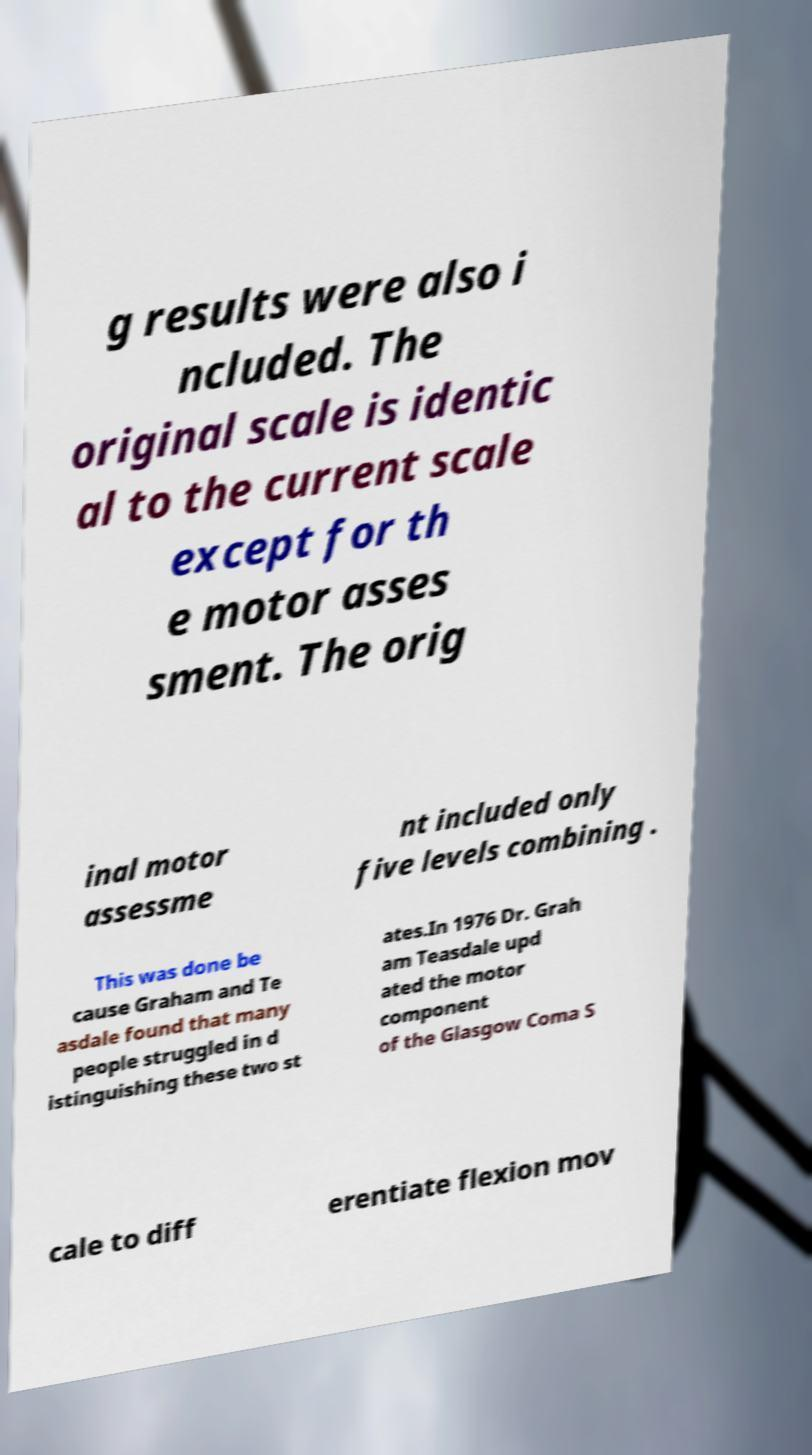For documentation purposes, I need the text within this image transcribed. Could you provide that? g results were also i ncluded. The original scale is identic al to the current scale except for th e motor asses sment. The orig inal motor assessme nt included only five levels combining . This was done be cause Graham and Te asdale found that many people struggled in d istinguishing these two st ates.In 1976 Dr. Grah am Teasdale upd ated the motor component of the Glasgow Coma S cale to diff erentiate flexion mov 